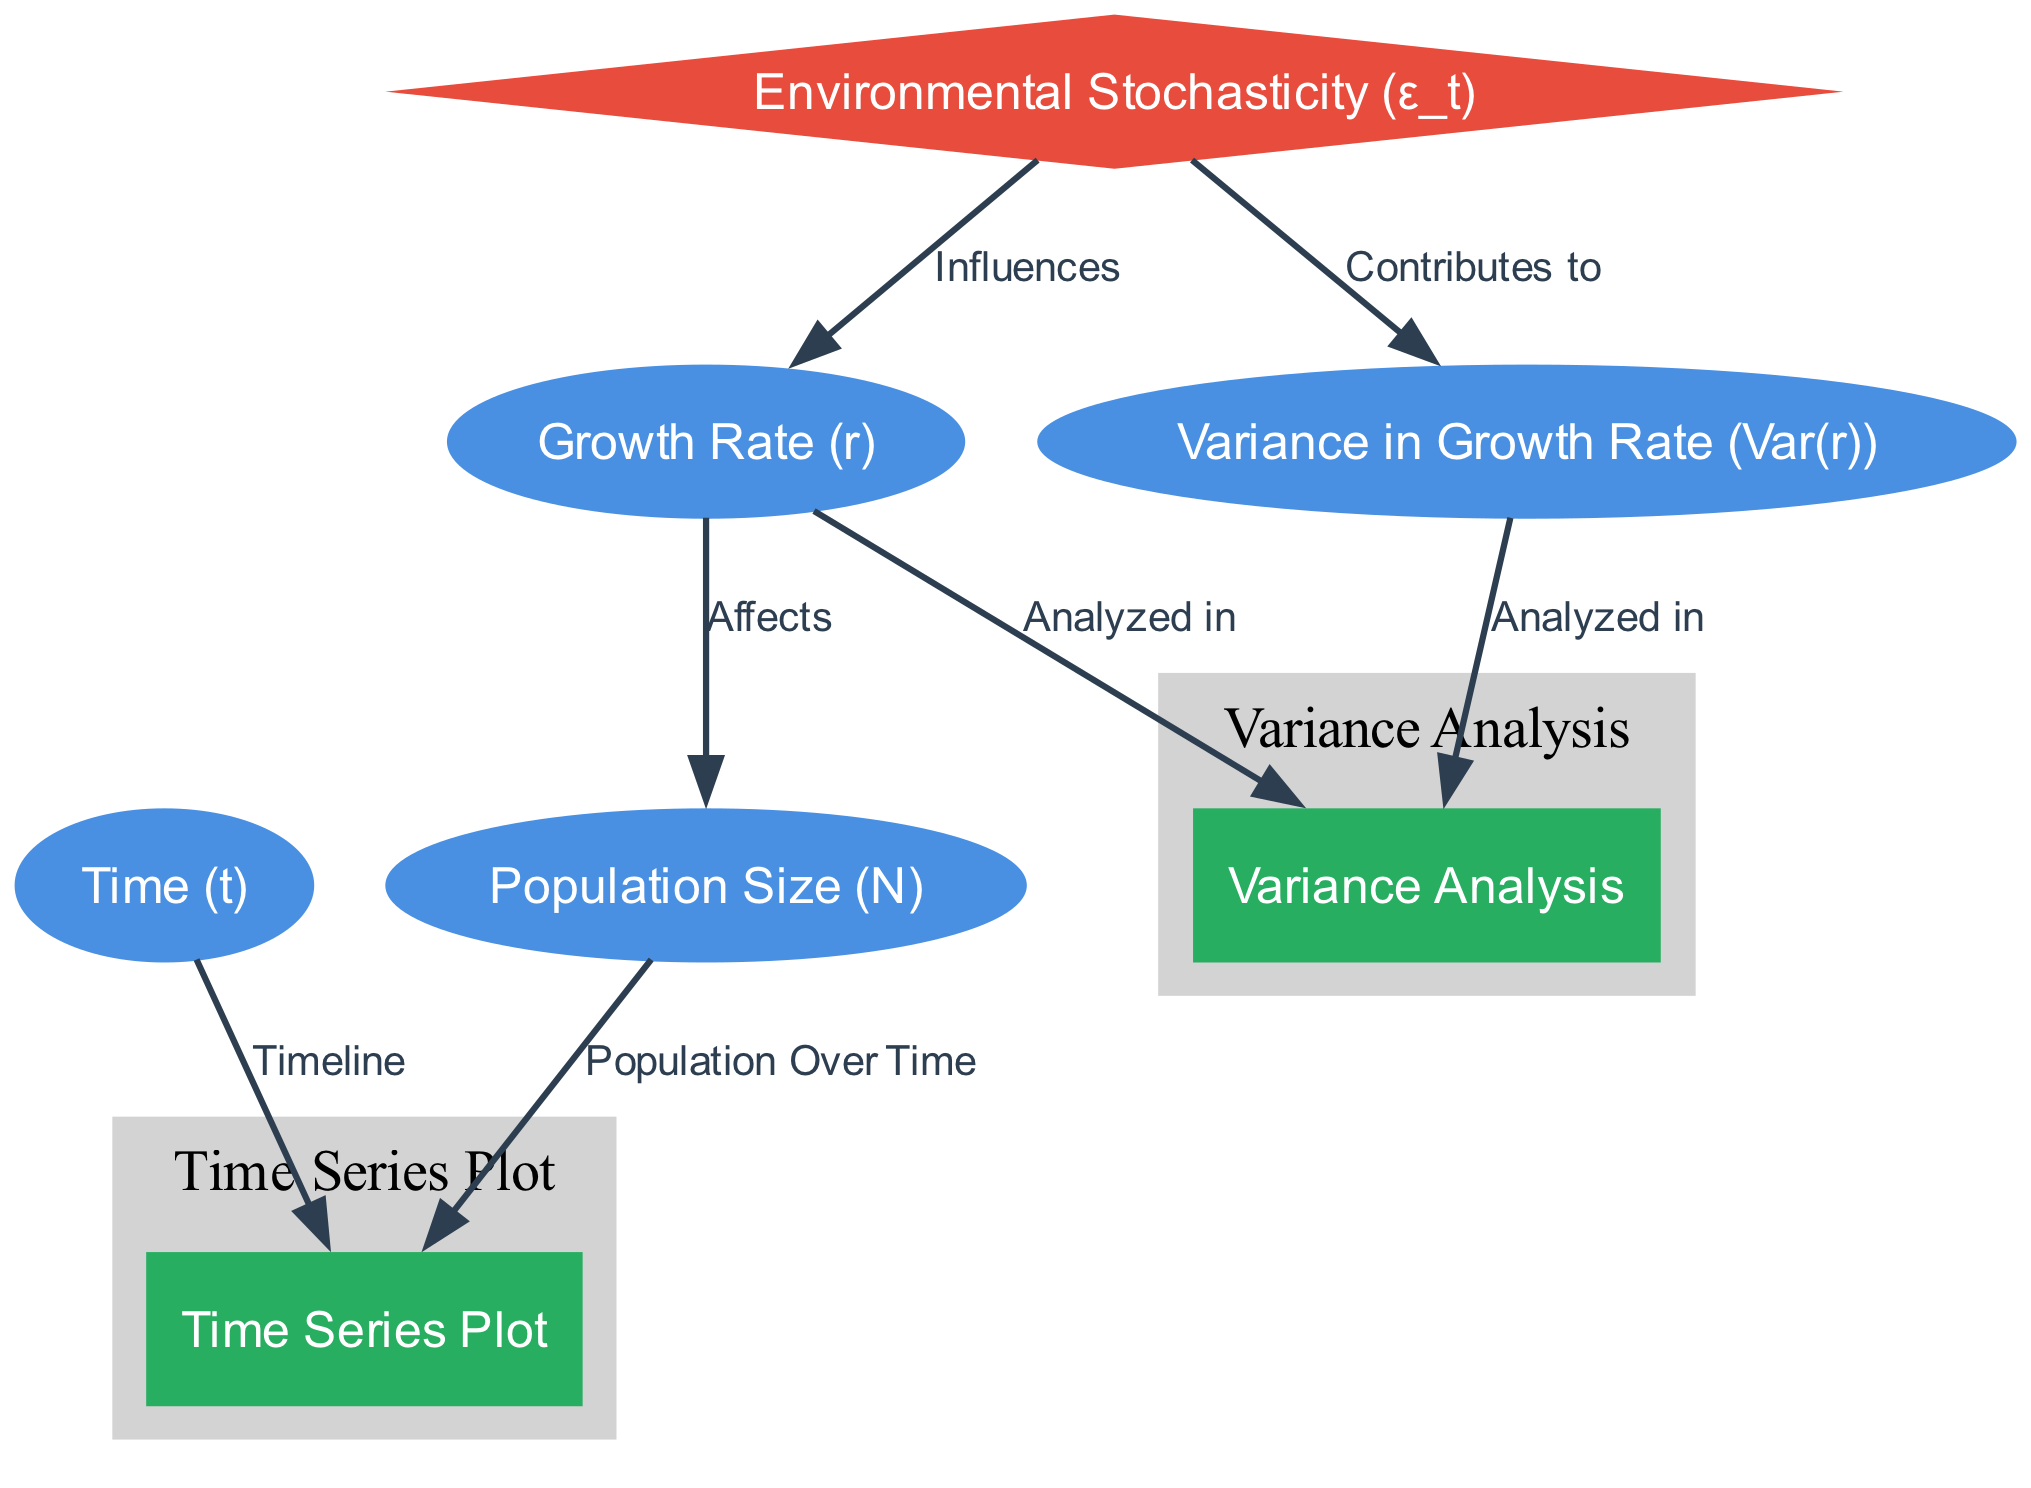What are the labels of the nodes in this diagram? The diagram contains the following node labels: Population Size (N), Time (t), Growth Rate (r), Environmental Stochasticity (ε_t), Variance in Growth Rate (Var(r)), Time Series Plot, and Variance Analysis.
Answer: Population Size (N), Time (t), Growth Rate (r), Environmental Stochasticity (ε_t), Variance in Growth Rate (Var(r)), Time Series Plot, Variance Analysis How many nodes are present in the diagram? Counting the listed nodes, there are seven nodes in total: Population Size (N), Time (t), Growth Rate (r), Environmental Stochasticity (ε_t), Variance in Growth Rate (Var(r)), Time Series Plot, and Variance Analysis.
Answer: Seven What is the effect of Growth Rate (r) on Population Size (N)? The diagram indicates a direct connection from Growth Rate (r) to Population Size (N), suggesting that changes in the growth rate directly affect population size over time.
Answer: Affects Which node contributes to the Variance in Growth Rate (Var(r))? The diagram shows that Environmental Stochasticity (ε_t) has an edge leading to Variance in Growth Rate (Var(r)), indicating that environmental factors contribute to variability in growth rates.
Answer: Environmental Stochasticity (ε_t) Explain how Environmental Stochasticity (ε_t) influences Growth Rate (r) and Variance in Growth Rate (Var(r)). Environmental Stochasticity (ε_t) has a direct influence on Growth Rate (r) as shown by the arrow, suggesting that changing environmental conditions affect growth rates. Additionally, it contributes to Variance in Growth Rate (Var(r)), demonstrating that such stochastic changes result in variability in growth among populations. Hence, both connections indicate a dual constancy of influence: direct effect on the rate and a broader impact on its variance.
Answer: Influences Growth Rate (r) and Contributes to Variance in Growth Rate (Var(r)) How is the Time Series Plot related to Population Size (N) and Time (t)? The arrows in the diagram illustrate that both Population Size (N) and Time (t) lead to the Time Series Plot, indicating that the plot visually represents population size across a timeline.
Answer: Timeline, Population Over Time What is analyzed in Variance Analysis? The diagram shows that both Variance in Growth Rate (Var(r)) and Growth Rate (r) are analyzed in the Variance Analysis node, indicating that this analysis focuses on understanding the variability within these aspects.
Answer: Variance in Growth Rate (Var(r)), Growth Rate (r) How many edges connect the nodes in the diagram? By reviewing the connections between the nodes, there are six edges that link the different nodes, illustrating how they interact with each other in the context of population dynamics.
Answer: Six 